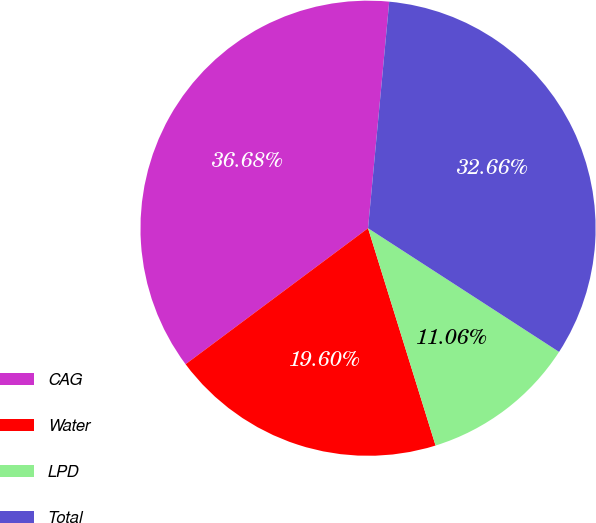<chart> <loc_0><loc_0><loc_500><loc_500><pie_chart><fcel>CAG<fcel>Water<fcel>LPD<fcel>Total<nl><fcel>36.68%<fcel>19.6%<fcel>11.06%<fcel>32.66%<nl></chart> 